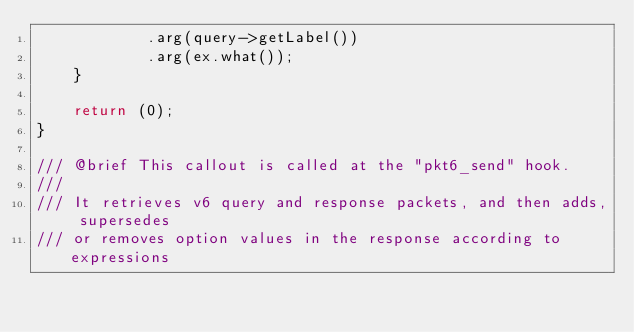Convert code to text. <code><loc_0><loc_0><loc_500><loc_500><_C++_>            .arg(query->getLabel())
            .arg(ex.what());
    }

    return (0);
}

/// @brief This callout is called at the "pkt6_send" hook.
///
/// It retrieves v6 query and response packets, and then adds, supersedes
/// or removes option values in the response according to expressions</code> 